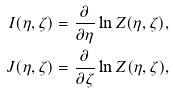Convert formula to latex. <formula><loc_0><loc_0><loc_500><loc_500>I ( \eta , \zeta ) & = \frac { \partial } { \partial \eta } \ln Z ( \eta , \zeta ) , \\ J ( \eta , \zeta ) & = \frac { \partial } { \partial \zeta } \ln Z ( \eta , \zeta ) ,</formula> 